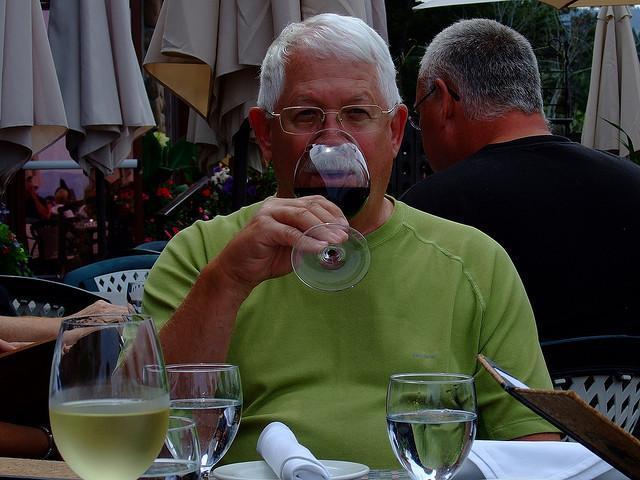How many shirts are black?
Give a very brief answer. 1. How many glasses are in the photo?
Give a very brief answer. 4. How many wine glasses are there?
Give a very brief answer. 5. How many people can be seen?
Give a very brief answer. 3. How many chairs are there?
Give a very brief answer. 3. How many umbrellas are visible?
Give a very brief answer. 4. How many trucks are not facing the camera?
Give a very brief answer. 0. 